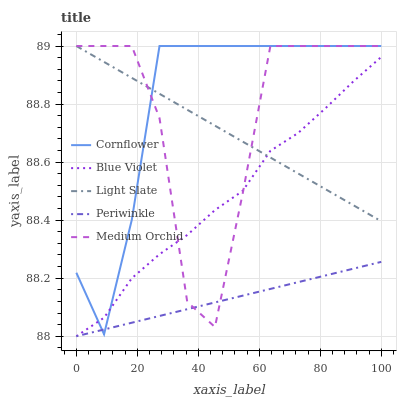Does Periwinkle have the minimum area under the curve?
Answer yes or no. Yes. Does Cornflower have the maximum area under the curve?
Answer yes or no. Yes. Does Medium Orchid have the minimum area under the curve?
Answer yes or no. No. Does Medium Orchid have the maximum area under the curve?
Answer yes or no. No. Is Periwinkle the smoothest?
Answer yes or no. Yes. Is Medium Orchid the roughest?
Answer yes or no. Yes. Is Cornflower the smoothest?
Answer yes or no. No. Is Cornflower the roughest?
Answer yes or no. No. Does Periwinkle have the lowest value?
Answer yes or no. Yes. Does Cornflower have the lowest value?
Answer yes or no. No. Does Medium Orchid have the highest value?
Answer yes or no. Yes. Does Periwinkle have the highest value?
Answer yes or no. No. Is Periwinkle less than Light Slate?
Answer yes or no. Yes. Is Light Slate greater than Periwinkle?
Answer yes or no. Yes. Does Blue Violet intersect Light Slate?
Answer yes or no. Yes. Is Blue Violet less than Light Slate?
Answer yes or no. No. Is Blue Violet greater than Light Slate?
Answer yes or no. No. Does Periwinkle intersect Light Slate?
Answer yes or no. No. 